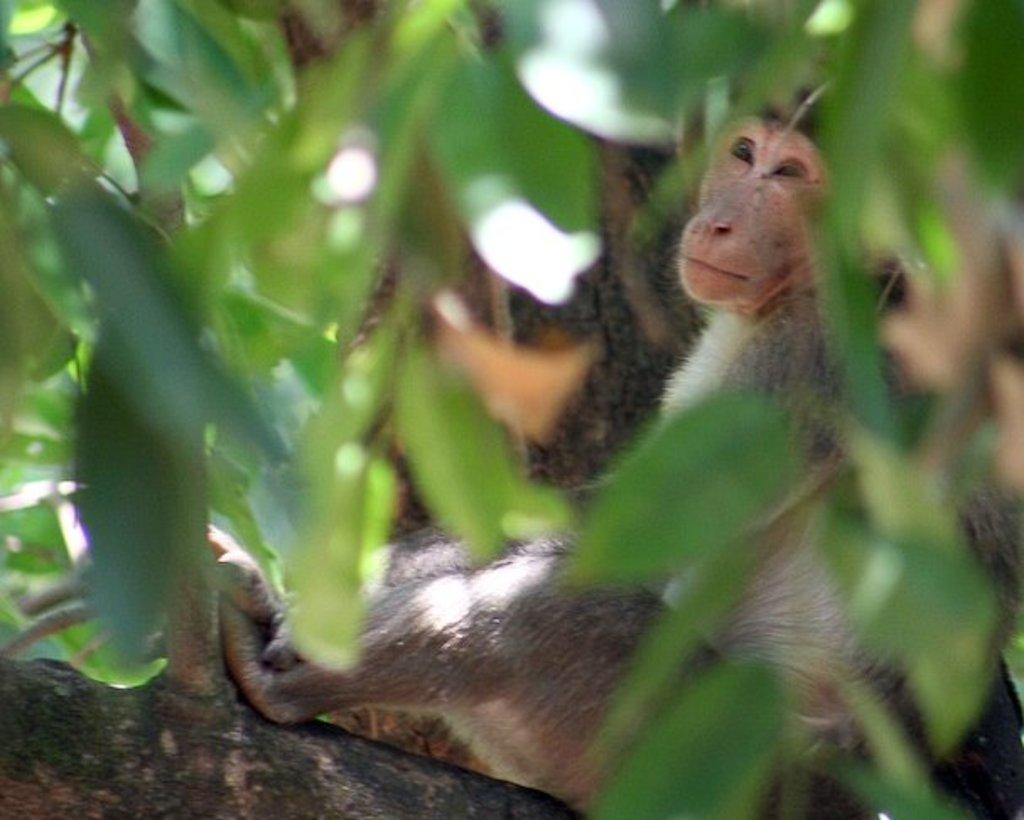Where was the image taken? The image was taken outdoors. What can be seen in the image besides the outdoor setting? There is a tree in the image. Is there any wildlife present in the image? Yes, there is a monkey on the tree in the image. What type of basin is visible in the image? There is no basin present in the image. Can you tell me how many teeth the monkey has in the image? It is not possible to determine the number of teeth the monkey has from the image. 